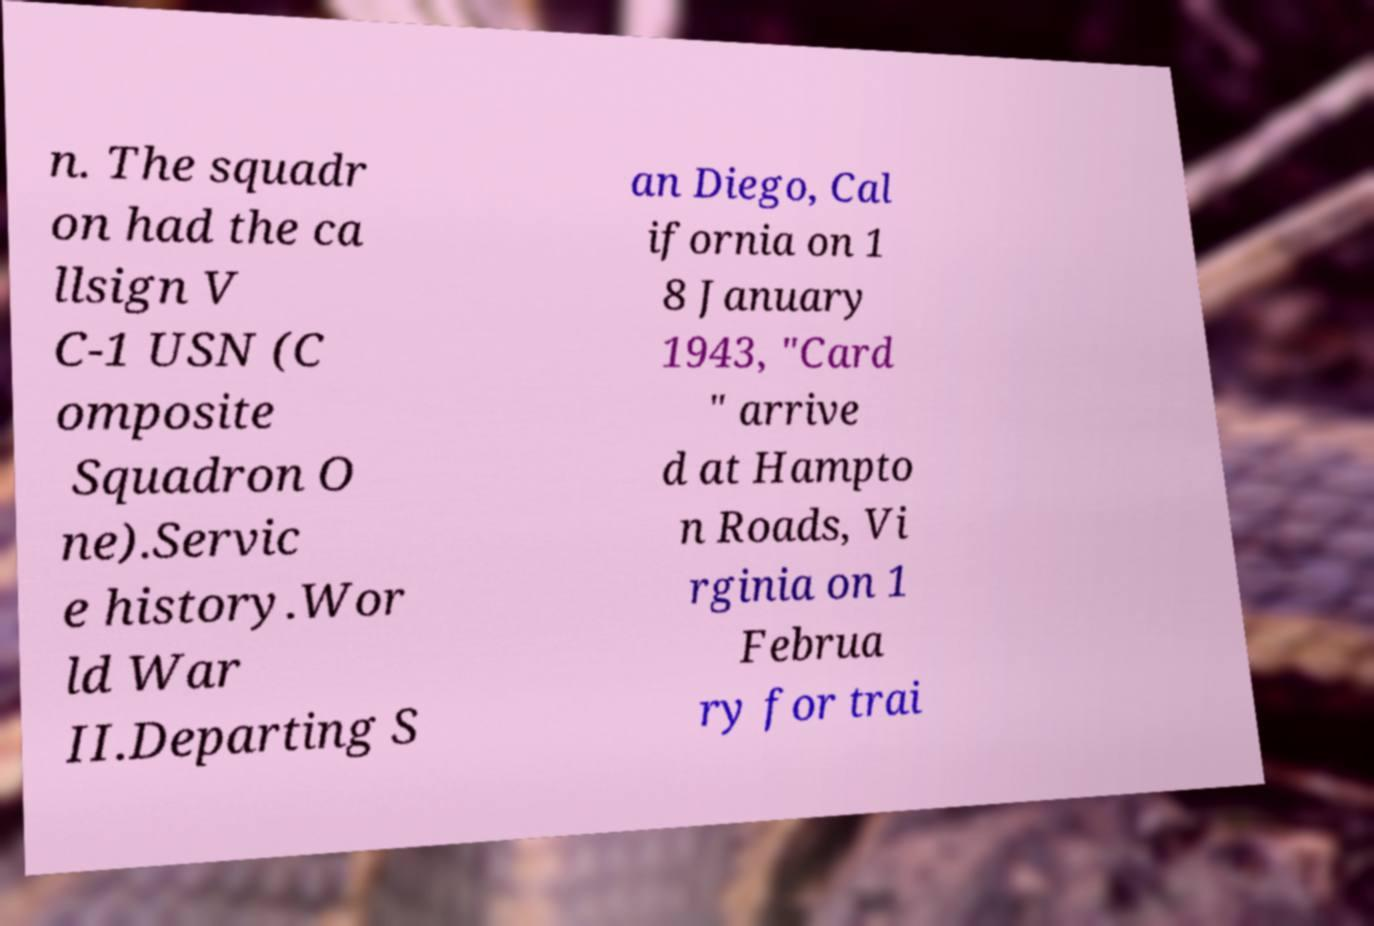I need the written content from this picture converted into text. Can you do that? n. The squadr on had the ca llsign V C-1 USN (C omposite Squadron O ne).Servic e history.Wor ld War II.Departing S an Diego, Cal ifornia on 1 8 January 1943, "Card " arrive d at Hampto n Roads, Vi rginia on 1 Februa ry for trai 